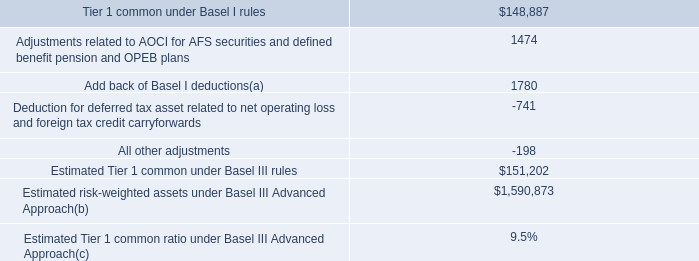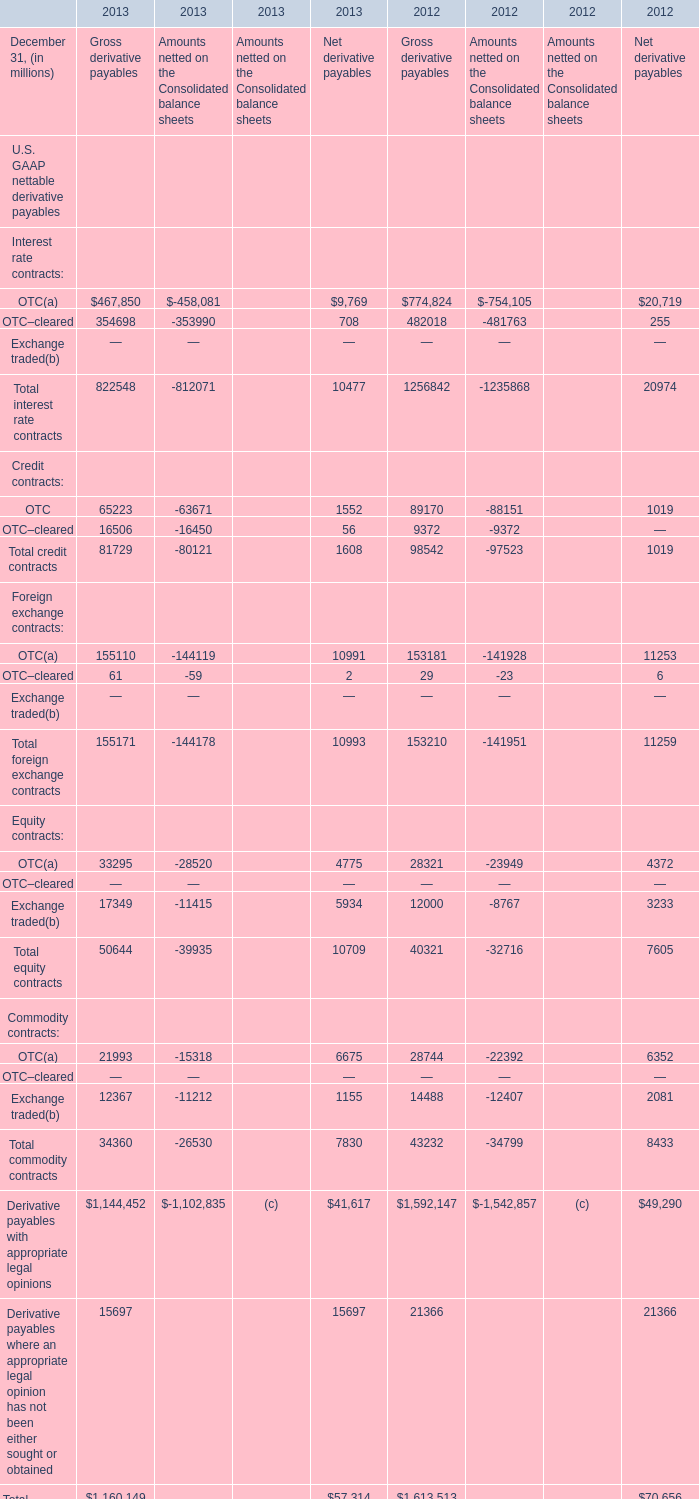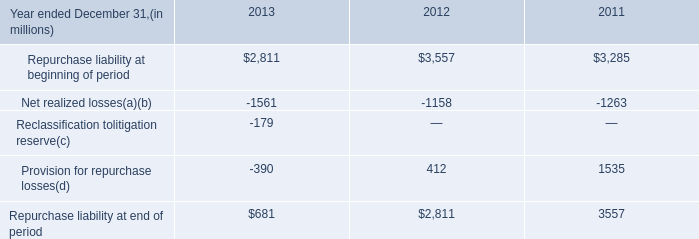Does Gross derivative payables of Credit contracts OTC keeps increasing each year between 2012 and 2013? 
Answer: yes. 